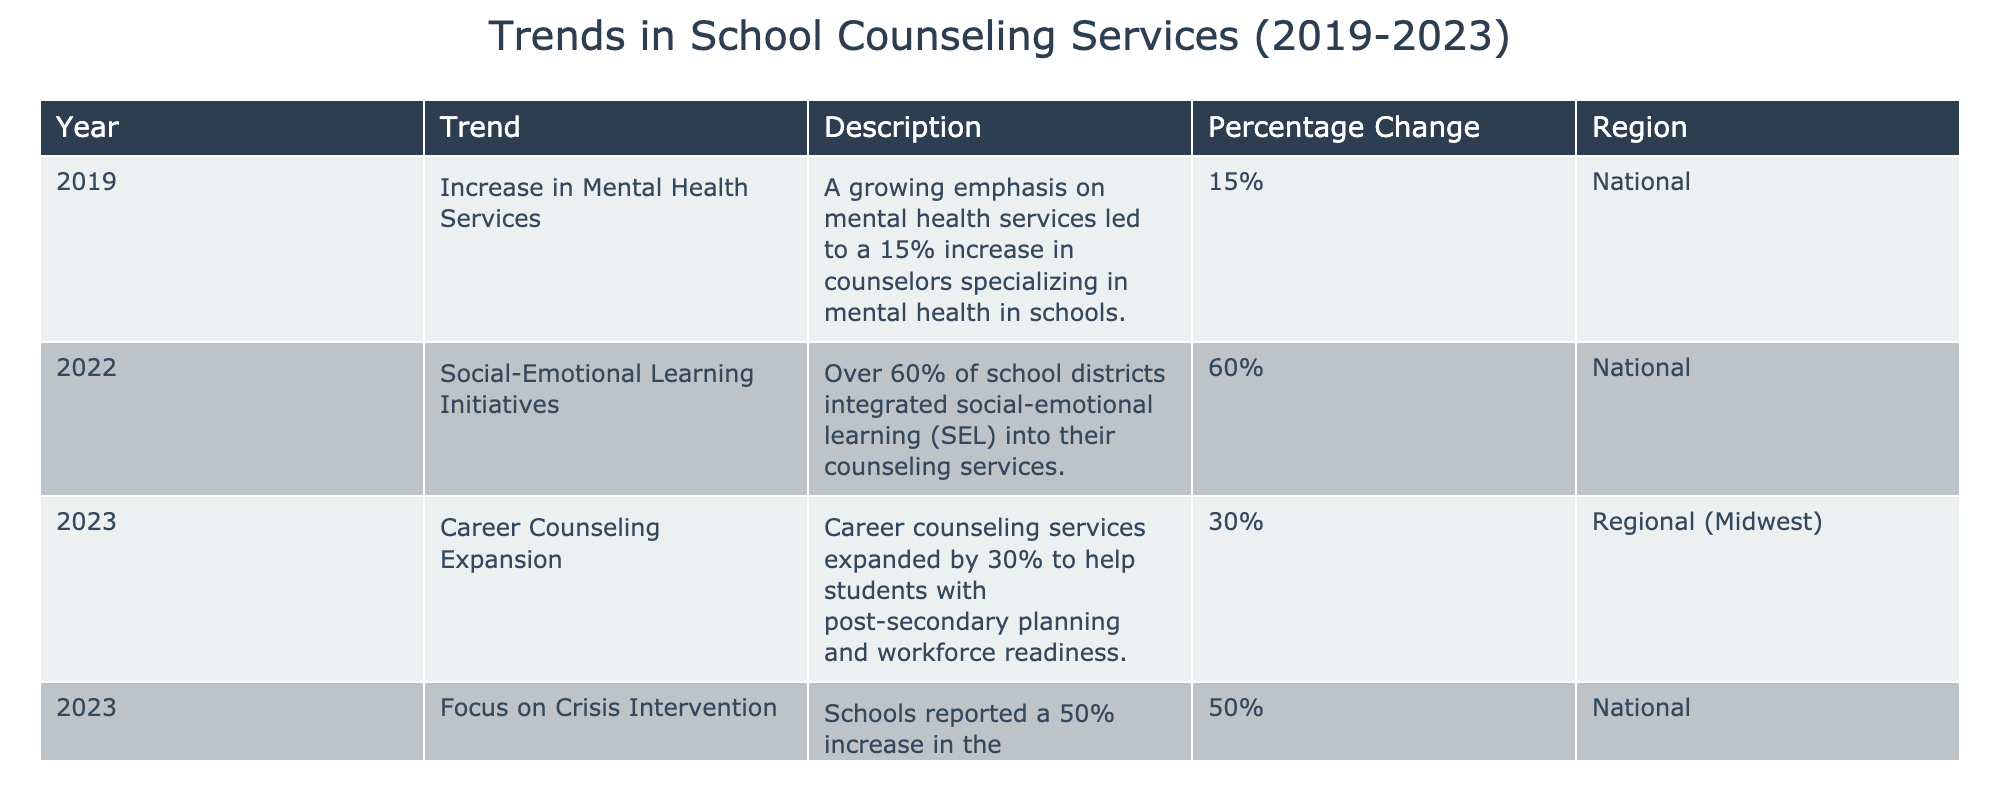What was the percentage increase in counselors specializing in mental health in 2019? According to the table, the percentage increase in counselors specializing in mental health in schools in 2019 was 15%.
Answer: 15% Which trend was reported in schools in 2022? The table indicates that in 2022, over 60% of school districts integrated social-emotional learning into their counseling services.
Answer: Social-Emotional Learning Initiatives Was there a focus on crisis intervention in schools in 2023? Yes, the table shows that schools reported a 50% increase in the implementation of crisis intervention programs within counseling services in 2023.
Answer: Yes What is the total percentage increase in counseling services from the years 2019 to 2023? To find the total percentage increase, we can look at the individual percentage increases: 15% in 2019 and 30% in 2023 (for career counseling) and 50% in crisis intervention (but not all are additive). There is no direct calculation for totals in increases from 2019 to 2023, so we cannot sum these percentages directly.
Answer: Cannot determine Which region had an expansion of career counseling services in 2023? The table specifies that the expansion of career counseling services in 2023 occurred in the Midwest region.
Answer: Regional (Midwest) What trend was similar in both 2022 and 2023? The trend of expanding services focused on student support, specifically social-emotional learning initiatives in 2022 and crisis intervention in 2023. Both aim to address student needs.
Answer: Similar focus on student support Was there a trend involving mental health services in 2022? No, the table does not mention any specific trend related to mental health services for the year 2022. The focus was on social-emotional learning initiatives.
Answer: No How much did crisis intervention programs increase compared to mental health services in 2019? Crisis intervention programs increased by 50% in 2023, while mental health services saw a 15% increase in 2019. The difference is 50% - 15% = 35%.
Answer: 35% more 